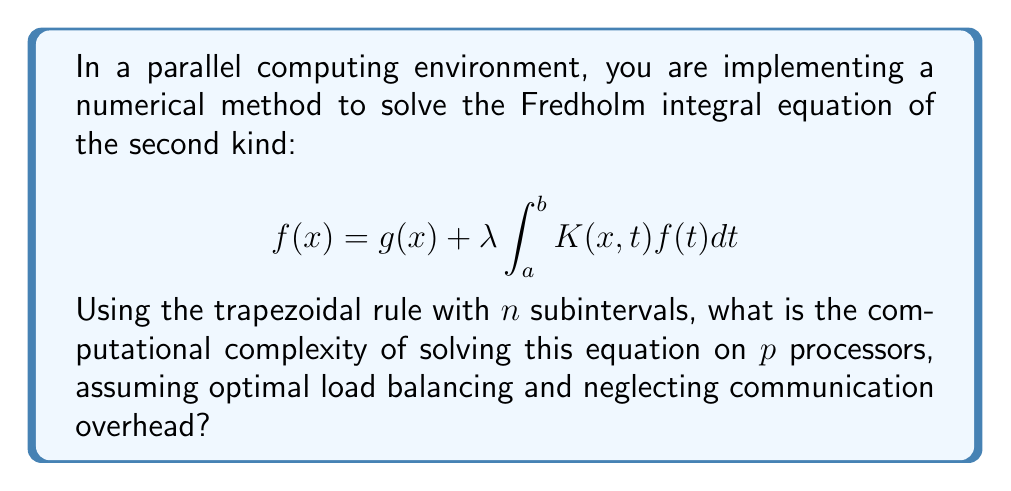Could you help me with this problem? To solve this problem, let's break it down into steps:

1) The trapezoidal rule for numerical integration with $n$ subintervals is:

   $$\int_a^b f(x)dx \approx \frac{b-a}{2n}\left[f(a) + 2\sum_{i=1}^{n-1}f(x_i) + f(b)\right]$$

2) Applying this to our integral equation, we need to calculate:

   $$f(x_j) = g(x_j) + \lambda \frac{b-a}{2n}\left[K(x_j,a)f(a) + 2\sum_{i=1}^{n-1}K(x_j,x_i)f(x_i) + K(x_j,b)f(b)\right]$$

   for $j = 1, 2, ..., n$.

3) This forms a system of $n$ linear equations with $n$ unknowns (the values of $f$ at the quadrature points).

4) The computational complexity of solving this system using Gaussian elimination is $O(n^3)$.

5) However, we're using $p$ processors in parallel. Assuming optimal load balancing, each processor will handle approximately $n/p$ equations.

6) The complexity of solving $n/p$ equations on each processor is $O((n/p)^3)$.

7) Since all processors work simultaneously, the overall complexity remains $O((n/p)^3)$.

Therefore, the computational complexity of solving this integral equation in a parallel environment with $p$ processors is $O((n/p)^3)$, where $n$ is the number of subintervals in the trapezoidal rule.
Answer: $O((n/p)^3)$ 